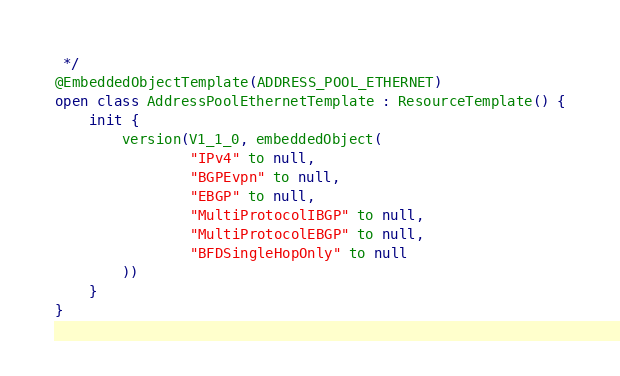Convert code to text. <code><loc_0><loc_0><loc_500><loc_500><_Kotlin_> */
@EmbeddedObjectTemplate(ADDRESS_POOL_ETHERNET)
open class AddressPoolEthernetTemplate : ResourceTemplate() {
    init {
        version(V1_1_0, embeddedObject(
                "IPv4" to null,
                "BGPEvpn" to null,
                "EBGP" to null,
                "MultiProtocolIBGP" to null,
                "MultiProtocolEBGP" to null,
                "BFDSingleHopOnly" to null
        ))
    }
}
</code> 